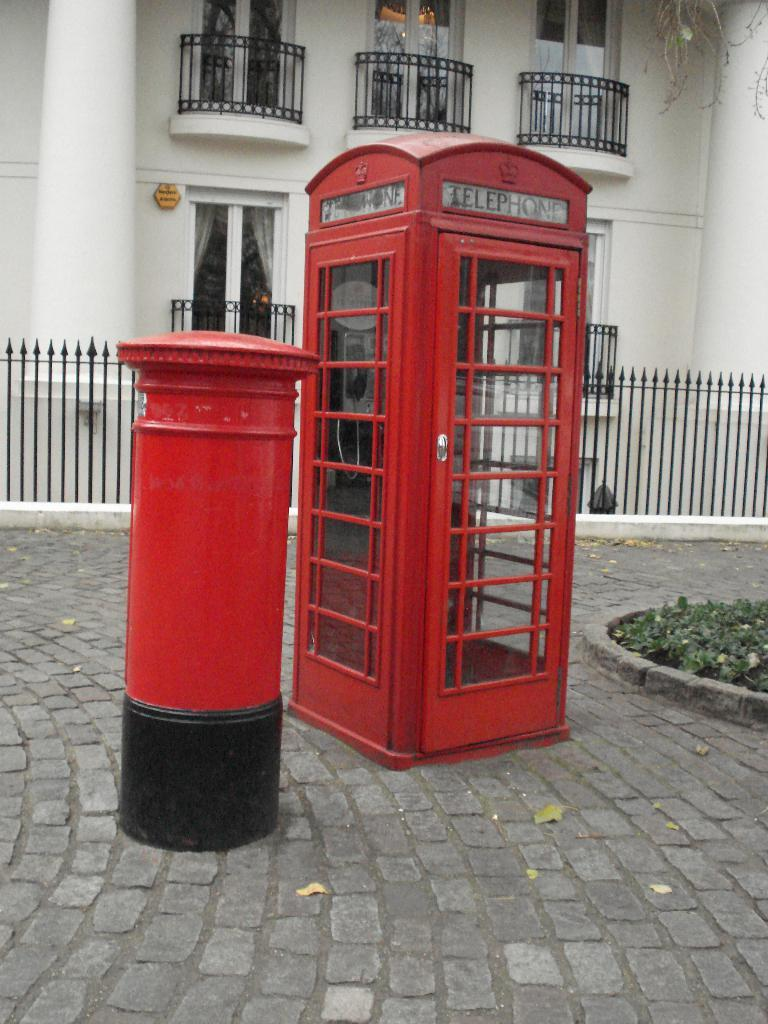<image>
Give a short and clear explanation of the subsequent image. A red telephone booth sits by a thick, short red pole. 